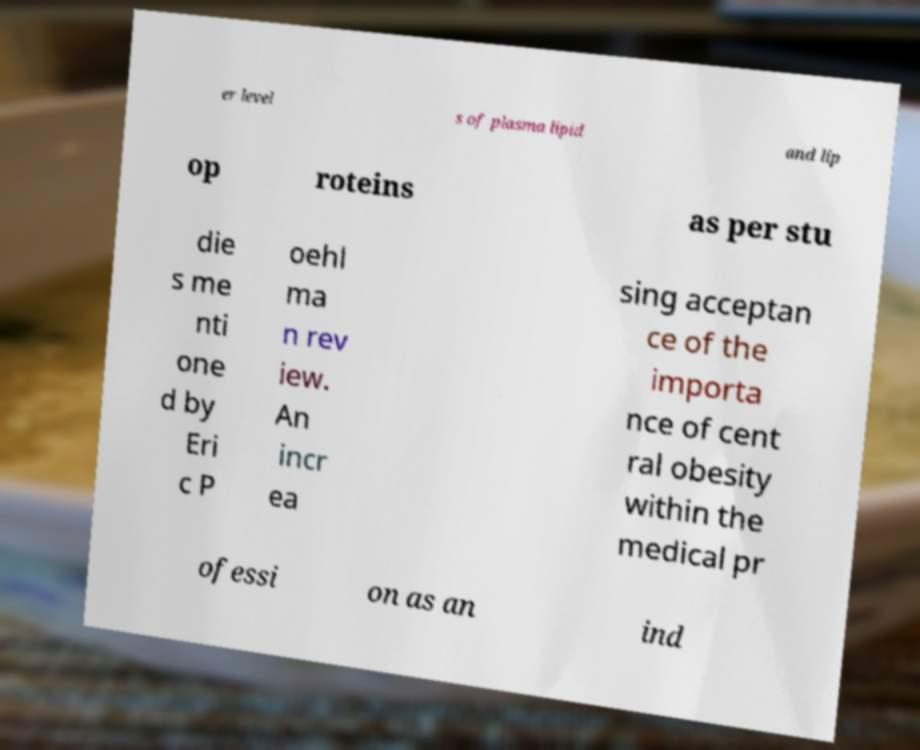What messages or text are displayed in this image? I need them in a readable, typed format. er level s of plasma lipid and lip op roteins as per stu die s me nti one d by Eri c P oehl ma n rev iew. An incr ea sing acceptan ce of the importa nce of cent ral obesity within the medical pr ofessi on as an ind 